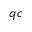<formula> <loc_0><loc_0><loc_500><loc_500>q c</formula> 